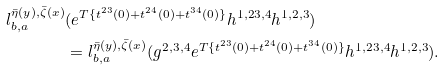Convert formula to latex. <formula><loc_0><loc_0><loc_500><loc_500>l ^ { \bar { \eta } ( y ) , \bar { \zeta } ( x ) } _ { b , a } & ( e ^ { T \{ t ^ { 2 3 } ( 0 ) + t ^ { 2 4 } ( 0 ) + t ^ { 3 4 } ( 0 ) \} } h ^ { 1 , 2 3 , 4 } h ^ { 1 , 2 , 3 } ) \\ & = l ^ { \bar { \eta } ( y ) , \bar { \zeta } ( x ) } _ { b , a } ( g ^ { 2 , 3 , 4 } e ^ { T \{ t ^ { 2 3 } ( 0 ) + t ^ { 2 4 } ( 0 ) + t ^ { 3 4 } ( 0 ) \} } h ^ { 1 , 2 3 , 4 } h ^ { 1 , 2 , 3 } ) .</formula> 